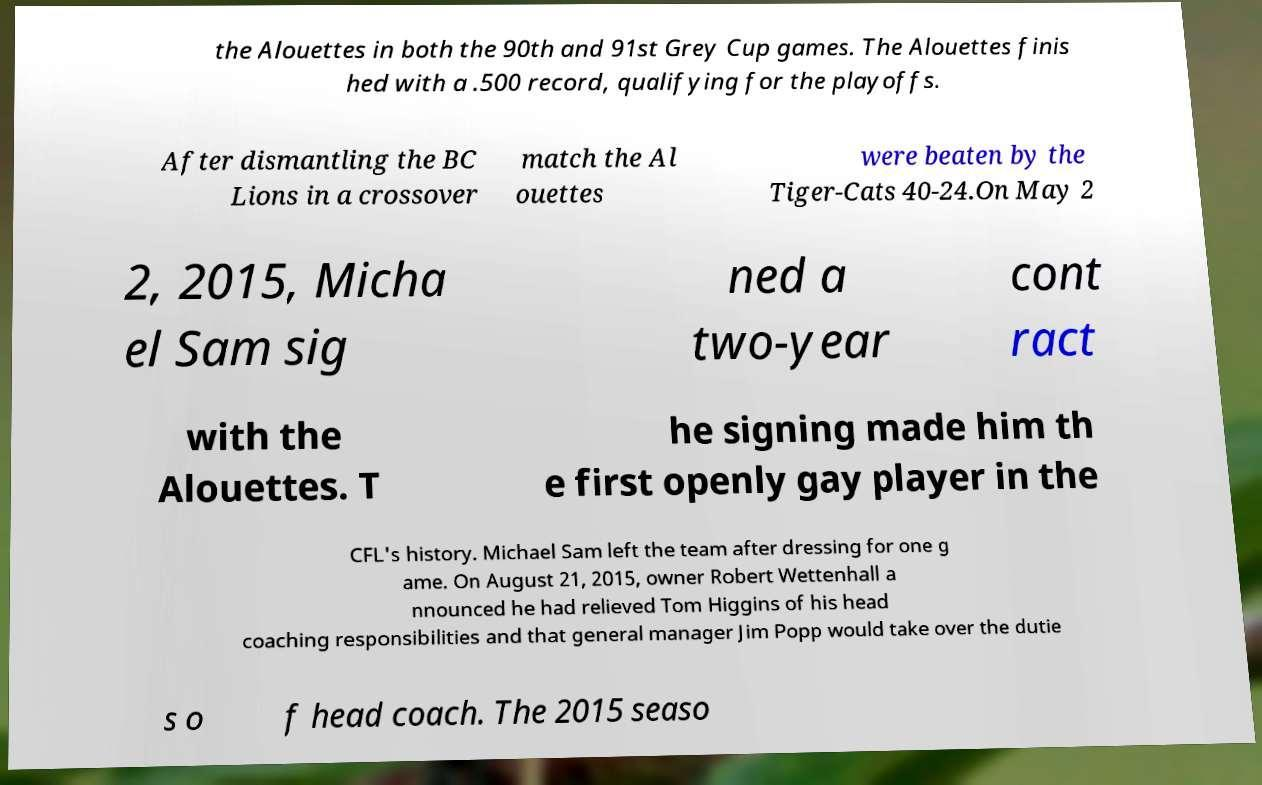There's text embedded in this image that I need extracted. Can you transcribe it verbatim? the Alouettes in both the 90th and 91st Grey Cup games. The Alouettes finis hed with a .500 record, qualifying for the playoffs. After dismantling the BC Lions in a crossover match the Al ouettes were beaten by the Tiger-Cats 40-24.On May 2 2, 2015, Micha el Sam sig ned a two-year cont ract with the Alouettes. T he signing made him th e first openly gay player in the CFL's history. Michael Sam left the team after dressing for one g ame. On August 21, 2015, owner Robert Wettenhall a nnounced he had relieved Tom Higgins of his head coaching responsibilities and that general manager Jim Popp would take over the dutie s o f head coach. The 2015 seaso 